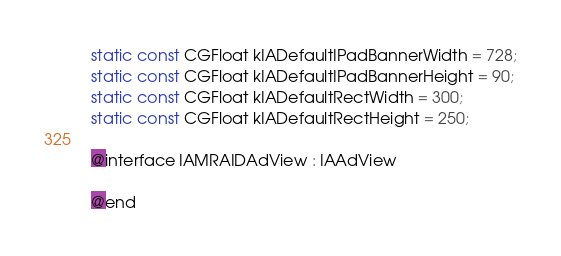<code> <loc_0><loc_0><loc_500><loc_500><_C_>static const CGFloat kIADefaultIPadBannerWidth = 728;
static const CGFloat kIADefaultIPadBannerHeight = 90;
static const CGFloat kIADefaultRectWidth = 300;
static const CGFloat kIADefaultRectHeight = 250;

@interface IAMRAIDAdView : IAAdView

@end
</code> 